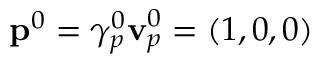Convert formula to latex. <formula><loc_0><loc_0><loc_500><loc_500>p ^ { 0 } = \gamma _ { p } ^ { 0 } v _ { p } ^ { 0 } = ( 1 , 0 , 0 )</formula> 